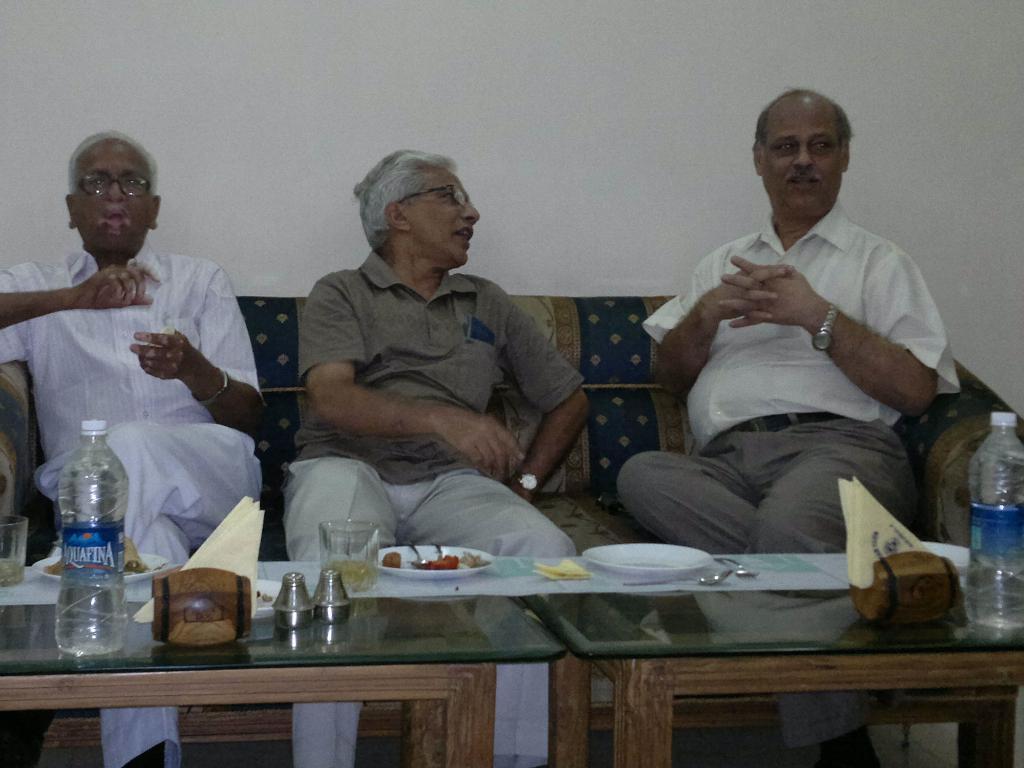How would you summarize this image in a sentence or two? In this image i can see 3 persons sitting on a couch in front of a table. On the table i can see few water bottles, few tissues, a glass and few plates. 